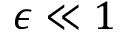Convert formula to latex. <formula><loc_0><loc_0><loc_500><loc_500>\epsilon \ll { 1 }</formula> 